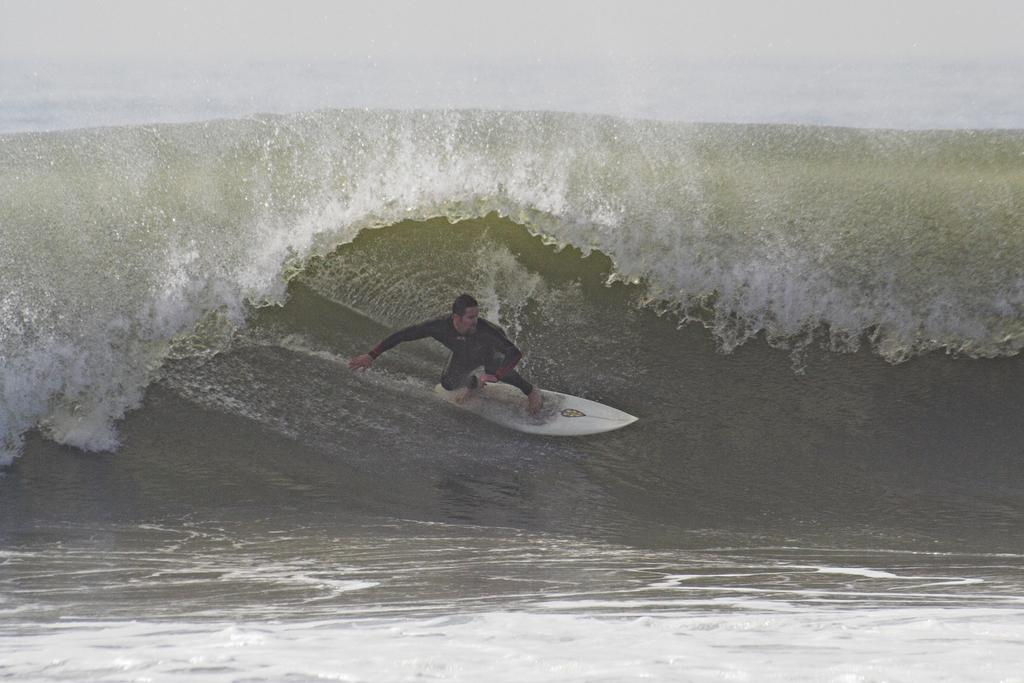Where was the image taken? The image was clicked outside the city. What activity is the person in the image engaged in? The person is surfing on a surfboard in the image. What can be seen in the background of the image? There are ripples in the water body visible in the background of the image. What type of bed is visible in the image? There is no bed present in the image; it features a person surfing on a surfboard outside the city. 